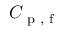Convert formula to latex. <formula><loc_0><loc_0><loc_500><loc_500>C _ { p , f }</formula> 